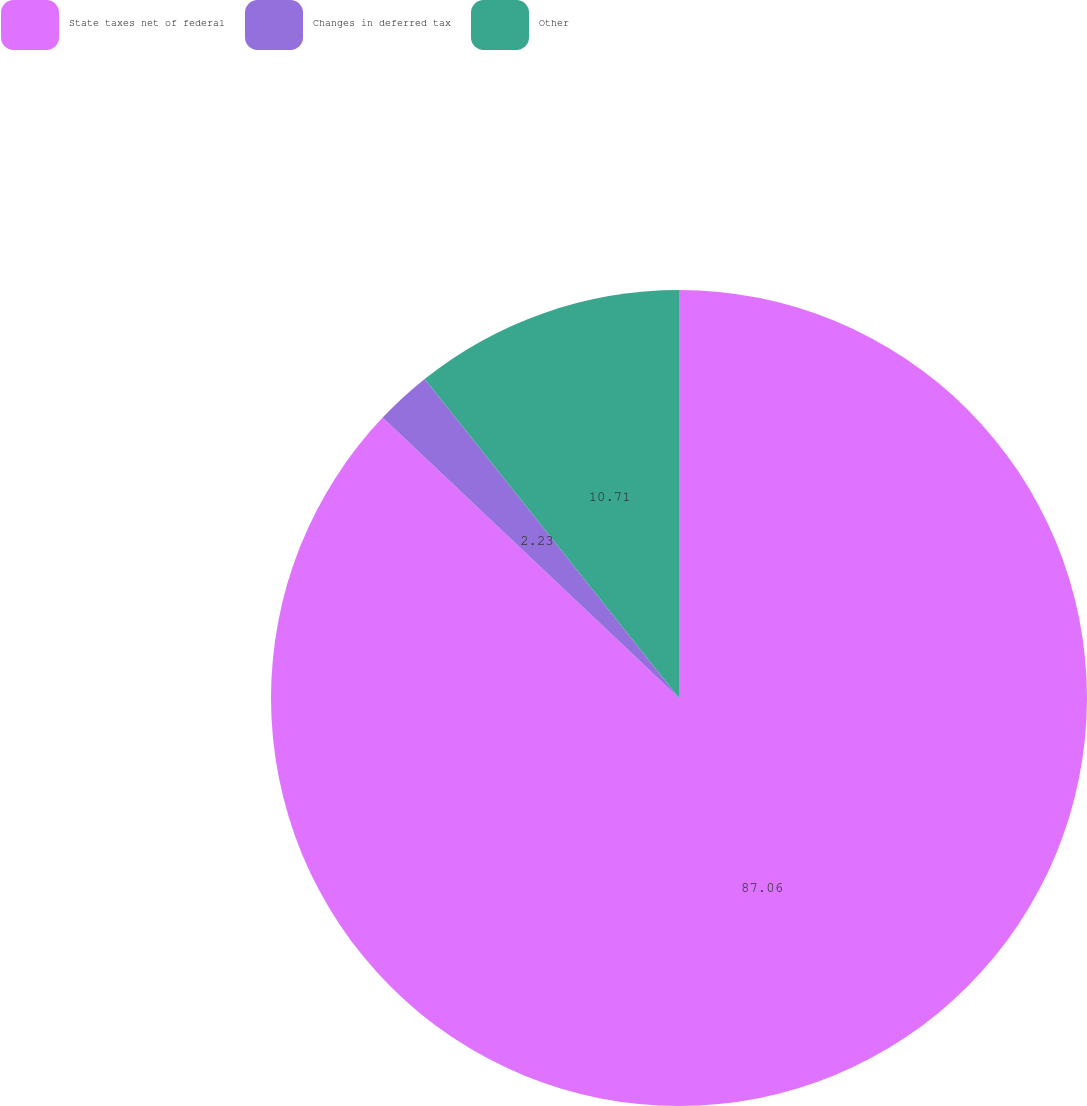Convert chart to OTSL. <chart><loc_0><loc_0><loc_500><loc_500><pie_chart><fcel>State taxes net of federal<fcel>Changes in deferred tax<fcel>Other<nl><fcel>87.05%<fcel>2.23%<fcel>10.71%<nl></chart> 